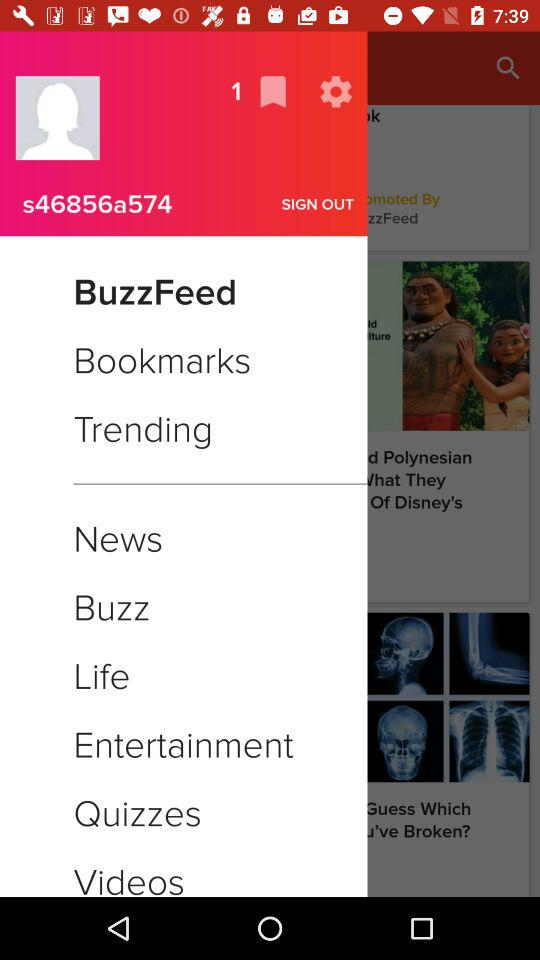How many saved items?
When the provided information is insufficient, respond with <no answer>. <no answer> 